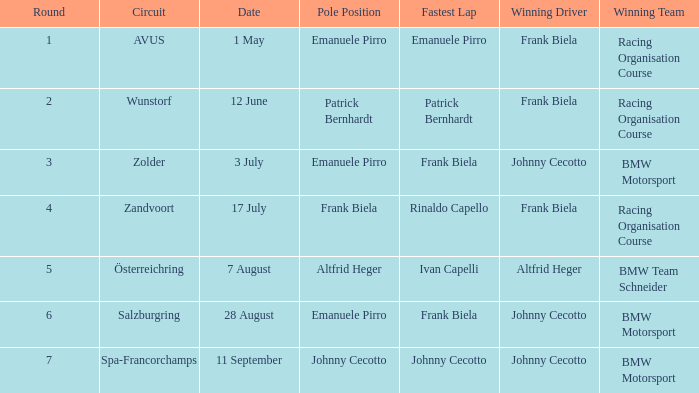At what round was the avus circuit featured? 1.0. 